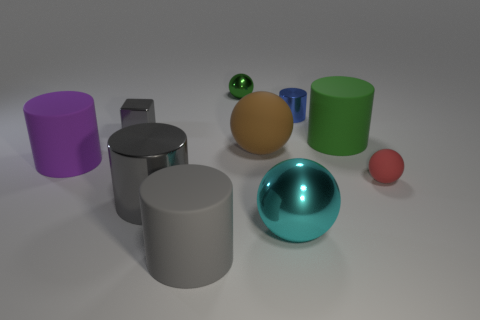Subtract 1 balls. How many balls are left? 3 Subtract all green cylinders. How many cylinders are left? 4 Subtract all gray matte cylinders. How many cylinders are left? 4 Subtract all red cylinders. Subtract all red spheres. How many cylinders are left? 5 Subtract all spheres. How many objects are left? 6 Add 6 blue metal cylinders. How many blue metal cylinders exist? 7 Subtract 0 blue balls. How many objects are left? 10 Subtract all brown rubber objects. Subtract all blue objects. How many objects are left? 8 Add 1 large rubber cylinders. How many large rubber cylinders are left? 4 